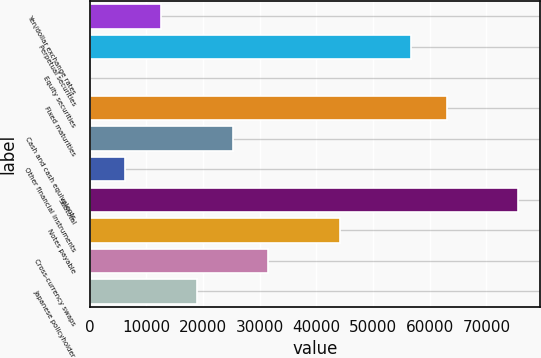Convert chart to OTSL. <chart><loc_0><loc_0><loc_500><loc_500><bar_chart><fcel>Yen/dollar exchange rates<fcel>Perpetual securities<fcel>Equity securities<fcel>Fixed maturities<fcel>Cash and cash equivalents<fcel>Other financial instruments<fcel>Subtotal<fcel>Notes payable<fcel>Cross-currency swaps<fcel>Japanese policyholder<nl><fcel>12623.4<fcel>56728.3<fcel>22<fcel>63029<fcel>25224.8<fcel>6322.7<fcel>75630.4<fcel>44126.9<fcel>31525.5<fcel>18924.1<nl></chart> 